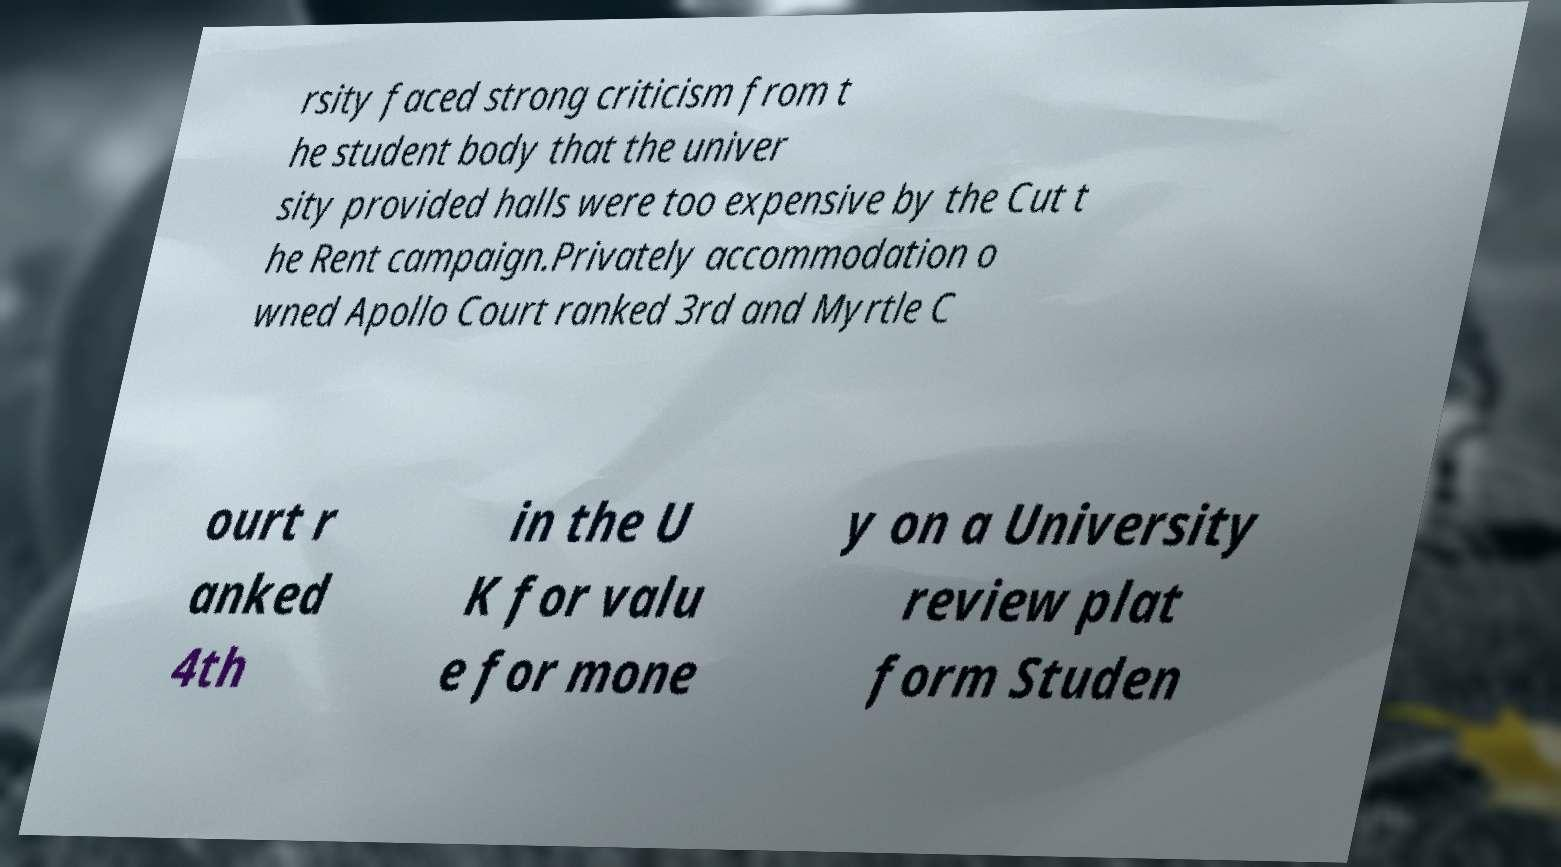Can you accurately transcribe the text from the provided image for me? rsity faced strong criticism from t he student body that the univer sity provided halls were too expensive by the Cut t he Rent campaign.Privately accommodation o wned Apollo Court ranked 3rd and Myrtle C ourt r anked 4th in the U K for valu e for mone y on a University review plat form Studen 